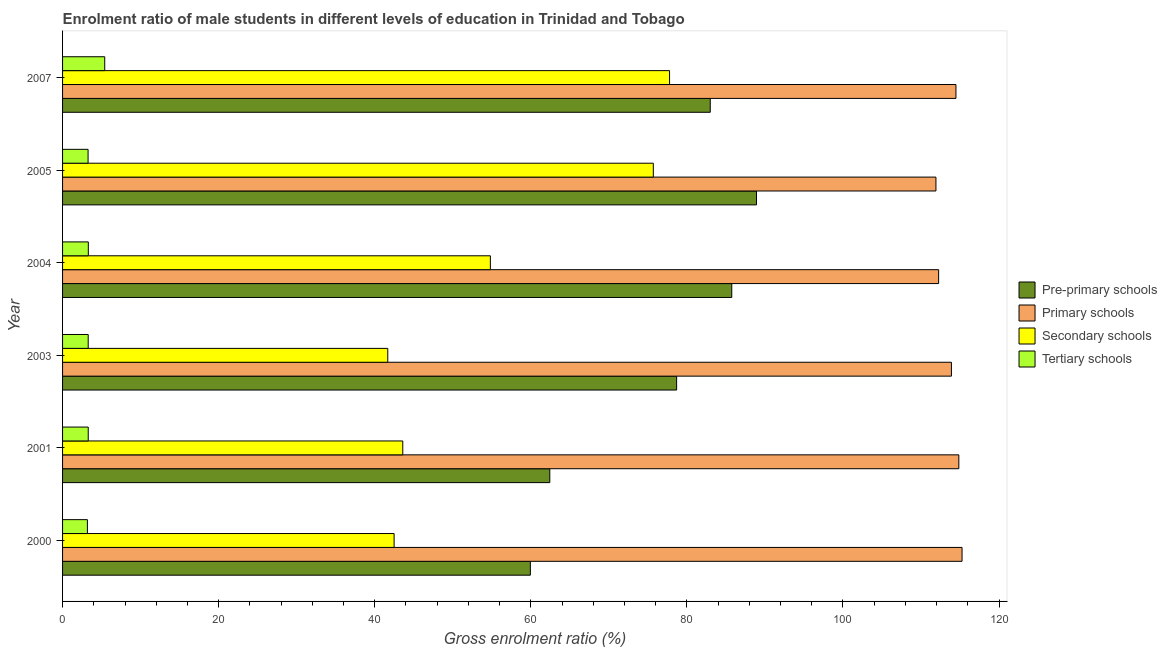Are the number of bars per tick equal to the number of legend labels?
Keep it short and to the point. Yes. How many bars are there on the 2nd tick from the top?
Provide a succinct answer. 4. How many bars are there on the 3rd tick from the bottom?
Give a very brief answer. 4. What is the label of the 6th group of bars from the top?
Provide a succinct answer. 2000. What is the gross enrolment ratio(female) in secondary schools in 2007?
Ensure brevity in your answer.  77.78. Across all years, what is the maximum gross enrolment ratio(female) in pre-primary schools?
Ensure brevity in your answer.  88.92. Across all years, what is the minimum gross enrolment ratio(female) in pre-primary schools?
Ensure brevity in your answer.  59.95. In which year was the gross enrolment ratio(female) in primary schools maximum?
Give a very brief answer. 2000. In which year was the gross enrolment ratio(female) in primary schools minimum?
Your answer should be compact. 2005. What is the total gross enrolment ratio(female) in tertiary schools in the graph?
Offer a very short reply. 21.73. What is the difference between the gross enrolment ratio(female) in primary schools in 2003 and that in 2005?
Ensure brevity in your answer.  1.98. What is the difference between the gross enrolment ratio(female) in secondary schools in 2000 and the gross enrolment ratio(female) in primary schools in 2001?
Keep it short and to the point. -72.37. What is the average gross enrolment ratio(female) in primary schools per year?
Offer a very short reply. 113.78. In the year 2000, what is the difference between the gross enrolment ratio(female) in secondary schools and gross enrolment ratio(female) in tertiary schools?
Make the answer very short. 39.3. What is the ratio of the gross enrolment ratio(female) in primary schools in 2000 to that in 2005?
Provide a succinct answer. 1.03. What is the difference between the highest and the second highest gross enrolment ratio(female) in primary schools?
Ensure brevity in your answer.  0.41. What is the difference between the highest and the lowest gross enrolment ratio(female) in pre-primary schools?
Make the answer very short. 28.98. Is the sum of the gross enrolment ratio(female) in pre-primary schools in 2004 and 2005 greater than the maximum gross enrolment ratio(female) in tertiary schools across all years?
Provide a short and direct response. Yes. What does the 4th bar from the top in 2004 represents?
Ensure brevity in your answer.  Pre-primary schools. What does the 3rd bar from the bottom in 2004 represents?
Make the answer very short. Secondary schools. Is it the case that in every year, the sum of the gross enrolment ratio(female) in pre-primary schools and gross enrolment ratio(female) in primary schools is greater than the gross enrolment ratio(female) in secondary schools?
Your answer should be compact. Yes. How many years are there in the graph?
Keep it short and to the point. 6. What is the difference between two consecutive major ticks on the X-axis?
Provide a short and direct response. 20. Are the values on the major ticks of X-axis written in scientific E-notation?
Make the answer very short. No. Where does the legend appear in the graph?
Keep it short and to the point. Center right. How many legend labels are there?
Your answer should be compact. 4. How are the legend labels stacked?
Your answer should be compact. Vertical. What is the title of the graph?
Give a very brief answer. Enrolment ratio of male students in different levels of education in Trinidad and Tobago. Does "Corruption" appear as one of the legend labels in the graph?
Your response must be concise. No. What is the Gross enrolment ratio (%) of Pre-primary schools in 2000?
Make the answer very short. 59.95. What is the Gross enrolment ratio (%) in Primary schools in 2000?
Offer a terse response. 115.27. What is the Gross enrolment ratio (%) in Secondary schools in 2000?
Provide a succinct answer. 42.49. What is the Gross enrolment ratio (%) in Tertiary schools in 2000?
Your answer should be very brief. 3.18. What is the Gross enrolment ratio (%) in Pre-primary schools in 2001?
Your response must be concise. 62.44. What is the Gross enrolment ratio (%) in Primary schools in 2001?
Offer a very short reply. 114.85. What is the Gross enrolment ratio (%) in Secondary schools in 2001?
Your answer should be compact. 43.6. What is the Gross enrolment ratio (%) of Tertiary schools in 2001?
Offer a very short reply. 3.29. What is the Gross enrolment ratio (%) of Pre-primary schools in 2003?
Offer a terse response. 78.69. What is the Gross enrolment ratio (%) in Primary schools in 2003?
Give a very brief answer. 113.9. What is the Gross enrolment ratio (%) in Secondary schools in 2003?
Your response must be concise. 41.67. What is the Gross enrolment ratio (%) of Tertiary schools in 2003?
Offer a terse response. 3.28. What is the Gross enrolment ratio (%) of Pre-primary schools in 2004?
Offer a very short reply. 85.75. What is the Gross enrolment ratio (%) in Primary schools in 2004?
Give a very brief answer. 112.26. What is the Gross enrolment ratio (%) of Secondary schools in 2004?
Make the answer very short. 54.82. What is the Gross enrolment ratio (%) in Tertiary schools in 2004?
Your answer should be very brief. 3.3. What is the Gross enrolment ratio (%) in Pre-primary schools in 2005?
Your answer should be very brief. 88.92. What is the Gross enrolment ratio (%) in Primary schools in 2005?
Your response must be concise. 111.92. What is the Gross enrolment ratio (%) of Secondary schools in 2005?
Your response must be concise. 75.7. What is the Gross enrolment ratio (%) of Tertiary schools in 2005?
Offer a terse response. 3.27. What is the Gross enrolment ratio (%) in Pre-primary schools in 2007?
Provide a short and direct response. 83. What is the Gross enrolment ratio (%) in Primary schools in 2007?
Give a very brief answer. 114.48. What is the Gross enrolment ratio (%) in Secondary schools in 2007?
Offer a very short reply. 77.78. What is the Gross enrolment ratio (%) of Tertiary schools in 2007?
Your response must be concise. 5.4. Across all years, what is the maximum Gross enrolment ratio (%) of Pre-primary schools?
Provide a short and direct response. 88.92. Across all years, what is the maximum Gross enrolment ratio (%) in Primary schools?
Ensure brevity in your answer.  115.27. Across all years, what is the maximum Gross enrolment ratio (%) of Secondary schools?
Keep it short and to the point. 77.78. Across all years, what is the maximum Gross enrolment ratio (%) in Tertiary schools?
Provide a short and direct response. 5.4. Across all years, what is the minimum Gross enrolment ratio (%) in Pre-primary schools?
Offer a very short reply. 59.95. Across all years, what is the minimum Gross enrolment ratio (%) in Primary schools?
Your response must be concise. 111.92. Across all years, what is the minimum Gross enrolment ratio (%) of Secondary schools?
Your answer should be very brief. 41.67. Across all years, what is the minimum Gross enrolment ratio (%) of Tertiary schools?
Offer a very short reply. 3.18. What is the total Gross enrolment ratio (%) in Pre-primary schools in the graph?
Your answer should be compact. 458.75. What is the total Gross enrolment ratio (%) of Primary schools in the graph?
Provide a short and direct response. 682.69. What is the total Gross enrolment ratio (%) in Secondary schools in the graph?
Your answer should be very brief. 336.06. What is the total Gross enrolment ratio (%) of Tertiary schools in the graph?
Give a very brief answer. 21.73. What is the difference between the Gross enrolment ratio (%) of Pre-primary schools in 2000 and that in 2001?
Your answer should be very brief. -2.49. What is the difference between the Gross enrolment ratio (%) of Primary schools in 2000 and that in 2001?
Your answer should be very brief. 0.41. What is the difference between the Gross enrolment ratio (%) in Secondary schools in 2000 and that in 2001?
Your response must be concise. -1.11. What is the difference between the Gross enrolment ratio (%) of Tertiary schools in 2000 and that in 2001?
Give a very brief answer. -0.1. What is the difference between the Gross enrolment ratio (%) of Pre-primary schools in 2000 and that in 2003?
Offer a very short reply. -18.74. What is the difference between the Gross enrolment ratio (%) of Primary schools in 2000 and that in 2003?
Make the answer very short. 1.36. What is the difference between the Gross enrolment ratio (%) in Secondary schools in 2000 and that in 2003?
Provide a succinct answer. 0.81. What is the difference between the Gross enrolment ratio (%) of Tertiary schools in 2000 and that in 2003?
Your answer should be very brief. -0.1. What is the difference between the Gross enrolment ratio (%) in Pre-primary schools in 2000 and that in 2004?
Your response must be concise. -25.81. What is the difference between the Gross enrolment ratio (%) of Primary schools in 2000 and that in 2004?
Ensure brevity in your answer.  3. What is the difference between the Gross enrolment ratio (%) of Secondary schools in 2000 and that in 2004?
Keep it short and to the point. -12.33. What is the difference between the Gross enrolment ratio (%) of Tertiary schools in 2000 and that in 2004?
Offer a very short reply. -0.12. What is the difference between the Gross enrolment ratio (%) of Pre-primary schools in 2000 and that in 2005?
Your answer should be compact. -28.98. What is the difference between the Gross enrolment ratio (%) of Primary schools in 2000 and that in 2005?
Provide a short and direct response. 3.35. What is the difference between the Gross enrolment ratio (%) in Secondary schools in 2000 and that in 2005?
Give a very brief answer. -33.22. What is the difference between the Gross enrolment ratio (%) in Tertiary schools in 2000 and that in 2005?
Your answer should be very brief. -0.09. What is the difference between the Gross enrolment ratio (%) in Pre-primary schools in 2000 and that in 2007?
Keep it short and to the point. -23.05. What is the difference between the Gross enrolment ratio (%) of Primary schools in 2000 and that in 2007?
Your answer should be very brief. 0.78. What is the difference between the Gross enrolment ratio (%) of Secondary schools in 2000 and that in 2007?
Offer a very short reply. -35.3. What is the difference between the Gross enrolment ratio (%) in Tertiary schools in 2000 and that in 2007?
Your answer should be very brief. -2.22. What is the difference between the Gross enrolment ratio (%) of Pre-primary schools in 2001 and that in 2003?
Offer a very short reply. -16.25. What is the difference between the Gross enrolment ratio (%) of Primary schools in 2001 and that in 2003?
Provide a succinct answer. 0.95. What is the difference between the Gross enrolment ratio (%) in Secondary schools in 2001 and that in 2003?
Your response must be concise. 1.92. What is the difference between the Gross enrolment ratio (%) in Tertiary schools in 2001 and that in 2003?
Keep it short and to the point. 0. What is the difference between the Gross enrolment ratio (%) of Pre-primary schools in 2001 and that in 2004?
Your response must be concise. -23.32. What is the difference between the Gross enrolment ratio (%) of Primary schools in 2001 and that in 2004?
Your answer should be very brief. 2.59. What is the difference between the Gross enrolment ratio (%) of Secondary schools in 2001 and that in 2004?
Offer a very short reply. -11.22. What is the difference between the Gross enrolment ratio (%) of Tertiary schools in 2001 and that in 2004?
Ensure brevity in your answer.  -0.01. What is the difference between the Gross enrolment ratio (%) of Pre-primary schools in 2001 and that in 2005?
Make the answer very short. -26.49. What is the difference between the Gross enrolment ratio (%) of Primary schools in 2001 and that in 2005?
Make the answer very short. 2.93. What is the difference between the Gross enrolment ratio (%) of Secondary schools in 2001 and that in 2005?
Make the answer very short. -32.1. What is the difference between the Gross enrolment ratio (%) in Tertiary schools in 2001 and that in 2005?
Your answer should be very brief. 0.02. What is the difference between the Gross enrolment ratio (%) in Pre-primary schools in 2001 and that in 2007?
Ensure brevity in your answer.  -20.56. What is the difference between the Gross enrolment ratio (%) of Primary schools in 2001 and that in 2007?
Keep it short and to the point. 0.37. What is the difference between the Gross enrolment ratio (%) in Secondary schools in 2001 and that in 2007?
Your answer should be very brief. -34.19. What is the difference between the Gross enrolment ratio (%) of Tertiary schools in 2001 and that in 2007?
Ensure brevity in your answer.  -2.11. What is the difference between the Gross enrolment ratio (%) in Pre-primary schools in 2003 and that in 2004?
Ensure brevity in your answer.  -7.07. What is the difference between the Gross enrolment ratio (%) of Primary schools in 2003 and that in 2004?
Ensure brevity in your answer.  1.64. What is the difference between the Gross enrolment ratio (%) in Secondary schools in 2003 and that in 2004?
Provide a succinct answer. -13.15. What is the difference between the Gross enrolment ratio (%) in Tertiary schools in 2003 and that in 2004?
Give a very brief answer. -0.02. What is the difference between the Gross enrolment ratio (%) in Pre-primary schools in 2003 and that in 2005?
Your answer should be very brief. -10.24. What is the difference between the Gross enrolment ratio (%) of Primary schools in 2003 and that in 2005?
Keep it short and to the point. 1.98. What is the difference between the Gross enrolment ratio (%) of Secondary schools in 2003 and that in 2005?
Your answer should be very brief. -34.03. What is the difference between the Gross enrolment ratio (%) in Tertiary schools in 2003 and that in 2005?
Give a very brief answer. 0.01. What is the difference between the Gross enrolment ratio (%) of Pre-primary schools in 2003 and that in 2007?
Offer a terse response. -4.31. What is the difference between the Gross enrolment ratio (%) of Primary schools in 2003 and that in 2007?
Offer a terse response. -0.58. What is the difference between the Gross enrolment ratio (%) of Secondary schools in 2003 and that in 2007?
Your response must be concise. -36.11. What is the difference between the Gross enrolment ratio (%) in Tertiary schools in 2003 and that in 2007?
Offer a terse response. -2.12. What is the difference between the Gross enrolment ratio (%) of Pre-primary schools in 2004 and that in 2005?
Your response must be concise. -3.17. What is the difference between the Gross enrolment ratio (%) in Primary schools in 2004 and that in 2005?
Keep it short and to the point. 0.34. What is the difference between the Gross enrolment ratio (%) of Secondary schools in 2004 and that in 2005?
Ensure brevity in your answer.  -20.88. What is the difference between the Gross enrolment ratio (%) in Tertiary schools in 2004 and that in 2005?
Your answer should be very brief. 0.03. What is the difference between the Gross enrolment ratio (%) in Pre-primary schools in 2004 and that in 2007?
Make the answer very short. 2.76. What is the difference between the Gross enrolment ratio (%) in Primary schools in 2004 and that in 2007?
Offer a terse response. -2.22. What is the difference between the Gross enrolment ratio (%) of Secondary schools in 2004 and that in 2007?
Your answer should be compact. -22.96. What is the difference between the Gross enrolment ratio (%) in Tertiary schools in 2004 and that in 2007?
Make the answer very short. -2.1. What is the difference between the Gross enrolment ratio (%) of Pre-primary schools in 2005 and that in 2007?
Make the answer very short. 5.93. What is the difference between the Gross enrolment ratio (%) in Primary schools in 2005 and that in 2007?
Make the answer very short. -2.56. What is the difference between the Gross enrolment ratio (%) of Secondary schools in 2005 and that in 2007?
Offer a very short reply. -2.08. What is the difference between the Gross enrolment ratio (%) of Tertiary schools in 2005 and that in 2007?
Provide a short and direct response. -2.13. What is the difference between the Gross enrolment ratio (%) of Pre-primary schools in 2000 and the Gross enrolment ratio (%) of Primary schools in 2001?
Offer a very short reply. -54.91. What is the difference between the Gross enrolment ratio (%) of Pre-primary schools in 2000 and the Gross enrolment ratio (%) of Secondary schools in 2001?
Keep it short and to the point. 16.35. What is the difference between the Gross enrolment ratio (%) in Pre-primary schools in 2000 and the Gross enrolment ratio (%) in Tertiary schools in 2001?
Ensure brevity in your answer.  56.66. What is the difference between the Gross enrolment ratio (%) in Primary schools in 2000 and the Gross enrolment ratio (%) in Secondary schools in 2001?
Offer a terse response. 71.67. What is the difference between the Gross enrolment ratio (%) of Primary schools in 2000 and the Gross enrolment ratio (%) of Tertiary schools in 2001?
Make the answer very short. 111.98. What is the difference between the Gross enrolment ratio (%) of Secondary schools in 2000 and the Gross enrolment ratio (%) of Tertiary schools in 2001?
Keep it short and to the point. 39.2. What is the difference between the Gross enrolment ratio (%) in Pre-primary schools in 2000 and the Gross enrolment ratio (%) in Primary schools in 2003?
Provide a succinct answer. -53.96. What is the difference between the Gross enrolment ratio (%) in Pre-primary schools in 2000 and the Gross enrolment ratio (%) in Secondary schools in 2003?
Offer a very short reply. 18.27. What is the difference between the Gross enrolment ratio (%) of Pre-primary schools in 2000 and the Gross enrolment ratio (%) of Tertiary schools in 2003?
Your response must be concise. 56.66. What is the difference between the Gross enrolment ratio (%) of Primary schools in 2000 and the Gross enrolment ratio (%) of Secondary schools in 2003?
Provide a succinct answer. 73.59. What is the difference between the Gross enrolment ratio (%) of Primary schools in 2000 and the Gross enrolment ratio (%) of Tertiary schools in 2003?
Give a very brief answer. 111.98. What is the difference between the Gross enrolment ratio (%) in Secondary schools in 2000 and the Gross enrolment ratio (%) in Tertiary schools in 2003?
Provide a succinct answer. 39.2. What is the difference between the Gross enrolment ratio (%) in Pre-primary schools in 2000 and the Gross enrolment ratio (%) in Primary schools in 2004?
Keep it short and to the point. -52.32. What is the difference between the Gross enrolment ratio (%) in Pre-primary schools in 2000 and the Gross enrolment ratio (%) in Secondary schools in 2004?
Keep it short and to the point. 5.12. What is the difference between the Gross enrolment ratio (%) in Pre-primary schools in 2000 and the Gross enrolment ratio (%) in Tertiary schools in 2004?
Offer a very short reply. 56.65. What is the difference between the Gross enrolment ratio (%) of Primary schools in 2000 and the Gross enrolment ratio (%) of Secondary schools in 2004?
Your response must be concise. 60.44. What is the difference between the Gross enrolment ratio (%) of Primary schools in 2000 and the Gross enrolment ratio (%) of Tertiary schools in 2004?
Give a very brief answer. 111.97. What is the difference between the Gross enrolment ratio (%) of Secondary schools in 2000 and the Gross enrolment ratio (%) of Tertiary schools in 2004?
Your answer should be compact. 39.19. What is the difference between the Gross enrolment ratio (%) of Pre-primary schools in 2000 and the Gross enrolment ratio (%) of Primary schools in 2005?
Your answer should be very brief. -51.97. What is the difference between the Gross enrolment ratio (%) in Pre-primary schools in 2000 and the Gross enrolment ratio (%) in Secondary schools in 2005?
Your answer should be compact. -15.76. What is the difference between the Gross enrolment ratio (%) in Pre-primary schools in 2000 and the Gross enrolment ratio (%) in Tertiary schools in 2005?
Ensure brevity in your answer.  56.68. What is the difference between the Gross enrolment ratio (%) in Primary schools in 2000 and the Gross enrolment ratio (%) in Secondary schools in 2005?
Provide a short and direct response. 39.56. What is the difference between the Gross enrolment ratio (%) of Primary schools in 2000 and the Gross enrolment ratio (%) of Tertiary schools in 2005?
Ensure brevity in your answer.  112. What is the difference between the Gross enrolment ratio (%) in Secondary schools in 2000 and the Gross enrolment ratio (%) in Tertiary schools in 2005?
Make the answer very short. 39.22. What is the difference between the Gross enrolment ratio (%) of Pre-primary schools in 2000 and the Gross enrolment ratio (%) of Primary schools in 2007?
Offer a very short reply. -54.54. What is the difference between the Gross enrolment ratio (%) of Pre-primary schools in 2000 and the Gross enrolment ratio (%) of Secondary schools in 2007?
Offer a terse response. -17.84. What is the difference between the Gross enrolment ratio (%) of Pre-primary schools in 2000 and the Gross enrolment ratio (%) of Tertiary schools in 2007?
Keep it short and to the point. 54.54. What is the difference between the Gross enrolment ratio (%) in Primary schools in 2000 and the Gross enrolment ratio (%) in Secondary schools in 2007?
Provide a succinct answer. 37.48. What is the difference between the Gross enrolment ratio (%) of Primary schools in 2000 and the Gross enrolment ratio (%) of Tertiary schools in 2007?
Provide a succinct answer. 109.86. What is the difference between the Gross enrolment ratio (%) of Secondary schools in 2000 and the Gross enrolment ratio (%) of Tertiary schools in 2007?
Keep it short and to the point. 37.08. What is the difference between the Gross enrolment ratio (%) in Pre-primary schools in 2001 and the Gross enrolment ratio (%) in Primary schools in 2003?
Your answer should be very brief. -51.47. What is the difference between the Gross enrolment ratio (%) in Pre-primary schools in 2001 and the Gross enrolment ratio (%) in Secondary schools in 2003?
Offer a very short reply. 20.76. What is the difference between the Gross enrolment ratio (%) in Pre-primary schools in 2001 and the Gross enrolment ratio (%) in Tertiary schools in 2003?
Make the answer very short. 59.15. What is the difference between the Gross enrolment ratio (%) in Primary schools in 2001 and the Gross enrolment ratio (%) in Secondary schools in 2003?
Offer a terse response. 73.18. What is the difference between the Gross enrolment ratio (%) in Primary schools in 2001 and the Gross enrolment ratio (%) in Tertiary schools in 2003?
Provide a succinct answer. 111.57. What is the difference between the Gross enrolment ratio (%) of Secondary schools in 2001 and the Gross enrolment ratio (%) of Tertiary schools in 2003?
Ensure brevity in your answer.  40.31. What is the difference between the Gross enrolment ratio (%) of Pre-primary schools in 2001 and the Gross enrolment ratio (%) of Primary schools in 2004?
Offer a very short reply. -49.83. What is the difference between the Gross enrolment ratio (%) in Pre-primary schools in 2001 and the Gross enrolment ratio (%) in Secondary schools in 2004?
Give a very brief answer. 7.62. What is the difference between the Gross enrolment ratio (%) of Pre-primary schools in 2001 and the Gross enrolment ratio (%) of Tertiary schools in 2004?
Make the answer very short. 59.14. What is the difference between the Gross enrolment ratio (%) in Primary schools in 2001 and the Gross enrolment ratio (%) in Secondary schools in 2004?
Your answer should be compact. 60.03. What is the difference between the Gross enrolment ratio (%) of Primary schools in 2001 and the Gross enrolment ratio (%) of Tertiary schools in 2004?
Ensure brevity in your answer.  111.55. What is the difference between the Gross enrolment ratio (%) of Secondary schools in 2001 and the Gross enrolment ratio (%) of Tertiary schools in 2004?
Give a very brief answer. 40.3. What is the difference between the Gross enrolment ratio (%) of Pre-primary schools in 2001 and the Gross enrolment ratio (%) of Primary schools in 2005?
Keep it short and to the point. -49.48. What is the difference between the Gross enrolment ratio (%) in Pre-primary schools in 2001 and the Gross enrolment ratio (%) in Secondary schools in 2005?
Offer a terse response. -13.27. What is the difference between the Gross enrolment ratio (%) of Pre-primary schools in 2001 and the Gross enrolment ratio (%) of Tertiary schools in 2005?
Offer a very short reply. 59.17. What is the difference between the Gross enrolment ratio (%) in Primary schools in 2001 and the Gross enrolment ratio (%) in Secondary schools in 2005?
Ensure brevity in your answer.  39.15. What is the difference between the Gross enrolment ratio (%) in Primary schools in 2001 and the Gross enrolment ratio (%) in Tertiary schools in 2005?
Give a very brief answer. 111.58. What is the difference between the Gross enrolment ratio (%) in Secondary schools in 2001 and the Gross enrolment ratio (%) in Tertiary schools in 2005?
Provide a succinct answer. 40.33. What is the difference between the Gross enrolment ratio (%) of Pre-primary schools in 2001 and the Gross enrolment ratio (%) of Primary schools in 2007?
Offer a very short reply. -52.05. What is the difference between the Gross enrolment ratio (%) in Pre-primary schools in 2001 and the Gross enrolment ratio (%) in Secondary schools in 2007?
Your answer should be very brief. -15.35. What is the difference between the Gross enrolment ratio (%) in Pre-primary schools in 2001 and the Gross enrolment ratio (%) in Tertiary schools in 2007?
Provide a short and direct response. 57.03. What is the difference between the Gross enrolment ratio (%) in Primary schools in 2001 and the Gross enrolment ratio (%) in Secondary schools in 2007?
Offer a very short reply. 37.07. What is the difference between the Gross enrolment ratio (%) in Primary schools in 2001 and the Gross enrolment ratio (%) in Tertiary schools in 2007?
Ensure brevity in your answer.  109.45. What is the difference between the Gross enrolment ratio (%) of Secondary schools in 2001 and the Gross enrolment ratio (%) of Tertiary schools in 2007?
Offer a very short reply. 38.19. What is the difference between the Gross enrolment ratio (%) in Pre-primary schools in 2003 and the Gross enrolment ratio (%) in Primary schools in 2004?
Offer a terse response. -33.57. What is the difference between the Gross enrolment ratio (%) in Pre-primary schools in 2003 and the Gross enrolment ratio (%) in Secondary schools in 2004?
Provide a short and direct response. 23.87. What is the difference between the Gross enrolment ratio (%) in Pre-primary schools in 2003 and the Gross enrolment ratio (%) in Tertiary schools in 2004?
Your response must be concise. 75.39. What is the difference between the Gross enrolment ratio (%) of Primary schools in 2003 and the Gross enrolment ratio (%) of Secondary schools in 2004?
Your response must be concise. 59.08. What is the difference between the Gross enrolment ratio (%) in Primary schools in 2003 and the Gross enrolment ratio (%) in Tertiary schools in 2004?
Provide a succinct answer. 110.6. What is the difference between the Gross enrolment ratio (%) of Secondary schools in 2003 and the Gross enrolment ratio (%) of Tertiary schools in 2004?
Provide a succinct answer. 38.37. What is the difference between the Gross enrolment ratio (%) of Pre-primary schools in 2003 and the Gross enrolment ratio (%) of Primary schools in 2005?
Give a very brief answer. -33.23. What is the difference between the Gross enrolment ratio (%) of Pre-primary schools in 2003 and the Gross enrolment ratio (%) of Secondary schools in 2005?
Offer a very short reply. 2.99. What is the difference between the Gross enrolment ratio (%) in Pre-primary schools in 2003 and the Gross enrolment ratio (%) in Tertiary schools in 2005?
Keep it short and to the point. 75.42. What is the difference between the Gross enrolment ratio (%) of Primary schools in 2003 and the Gross enrolment ratio (%) of Secondary schools in 2005?
Your answer should be very brief. 38.2. What is the difference between the Gross enrolment ratio (%) of Primary schools in 2003 and the Gross enrolment ratio (%) of Tertiary schools in 2005?
Make the answer very short. 110.63. What is the difference between the Gross enrolment ratio (%) of Secondary schools in 2003 and the Gross enrolment ratio (%) of Tertiary schools in 2005?
Offer a very short reply. 38.4. What is the difference between the Gross enrolment ratio (%) in Pre-primary schools in 2003 and the Gross enrolment ratio (%) in Primary schools in 2007?
Provide a succinct answer. -35.8. What is the difference between the Gross enrolment ratio (%) of Pre-primary schools in 2003 and the Gross enrolment ratio (%) of Secondary schools in 2007?
Provide a short and direct response. 0.91. What is the difference between the Gross enrolment ratio (%) of Pre-primary schools in 2003 and the Gross enrolment ratio (%) of Tertiary schools in 2007?
Offer a terse response. 73.29. What is the difference between the Gross enrolment ratio (%) in Primary schools in 2003 and the Gross enrolment ratio (%) in Secondary schools in 2007?
Offer a terse response. 36.12. What is the difference between the Gross enrolment ratio (%) in Primary schools in 2003 and the Gross enrolment ratio (%) in Tertiary schools in 2007?
Your answer should be compact. 108.5. What is the difference between the Gross enrolment ratio (%) in Secondary schools in 2003 and the Gross enrolment ratio (%) in Tertiary schools in 2007?
Offer a terse response. 36.27. What is the difference between the Gross enrolment ratio (%) of Pre-primary schools in 2004 and the Gross enrolment ratio (%) of Primary schools in 2005?
Make the answer very short. -26.16. What is the difference between the Gross enrolment ratio (%) in Pre-primary schools in 2004 and the Gross enrolment ratio (%) in Secondary schools in 2005?
Give a very brief answer. 10.05. What is the difference between the Gross enrolment ratio (%) in Pre-primary schools in 2004 and the Gross enrolment ratio (%) in Tertiary schools in 2005?
Offer a terse response. 82.48. What is the difference between the Gross enrolment ratio (%) of Primary schools in 2004 and the Gross enrolment ratio (%) of Secondary schools in 2005?
Provide a succinct answer. 36.56. What is the difference between the Gross enrolment ratio (%) of Primary schools in 2004 and the Gross enrolment ratio (%) of Tertiary schools in 2005?
Offer a terse response. 108.99. What is the difference between the Gross enrolment ratio (%) in Secondary schools in 2004 and the Gross enrolment ratio (%) in Tertiary schools in 2005?
Your response must be concise. 51.55. What is the difference between the Gross enrolment ratio (%) in Pre-primary schools in 2004 and the Gross enrolment ratio (%) in Primary schools in 2007?
Keep it short and to the point. -28.73. What is the difference between the Gross enrolment ratio (%) of Pre-primary schools in 2004 and the Gross enrolment ratio (%) of Secondary schools in 2007?
Your response must be concise. 7.97. What is the difference between the Gross enrolment ratio (%) in Pre-primary schools in 2004 and the Gross enrolment ratio (%) in Tertiary schools in 2007?
Offer a very short reply. 80.35. What is the difference between the Gross enrolment ratio (%) in Primary schools in 2004 and the Gross enrolment ratio (%) in Secondary schools in 2007?
Your answer should be compact. 34.48. What is the difference between the Gross enrolment ratio (%) of Primary schools in 2004 and the Gross enrolment ratio (%) of Tertiary schools in 2007?
Your answer should be compact. 106.86. What is the difference between the Gross enrolment ratio (%) in Secondary schools in 2004 and the Gross enrolment ratio (%) in Tertiary schools in 2007?
Your answer should be very brief. 49.42. What is the difference between the Gross enrolment ratio (%) in Pre-primary schools in 2005 and the Gross enrolment ratio (%) in Primary schools in 2007?
Keep it short and to the point. -25.56. What is the difference between the Gross enrolment ratio (%) in Pre-primary schools in 2005 and the Gross enrolment ratio (%) in Secondary schools in 2007?
Offer a terse response. 11.14. What is the difference between the Gross enrolment ratio (%) of Pre-primary schools in 2005 and the Gross enrolment ratio (%) of Tertiary schools in 2007?
Your answer should be very brief. 83.52. What is the difference between the Gross enrolment ratio (%) of Primary schools in 2005 and the Gross enrolment ratio (%) of Secondary schools in 2007?
Your answer should be very brief. 34.14. What is the difference between the Gross enrolment ratio (%) in Primary schools in 2005 and the Gross enrolment ratio (%) in Tertiary schools in 2007?
Offer a very short reply. 106.52. What is the difference between the Gross enrolment ratio (%) in Secondary schools in 2005 and the Gross enrolment ratio (%) in Tertiary schools in 2007?
Keep it short and to the point. 70.3. What is the average Gross enrolment ratio (%) of Pre-primary schools per year?
Your response must be concise. 76.46. What is the average Gross enrolment ratio (%) of Primary schools per year?
Your answer should be very brief. 113.78. What is the average Gross enrolment ratio (%) in Secondary schools per year?
Offer a terse response. 56.01. What is the average Gross enrolment ratio (%) in Tertiary schools per year?
Keep it short and to the point. 3.62. In the year 2000, what is the difference between the Gross enrolment ratio (%) in Pre-primary schools and Gross enrolment ratio (%) in Primary schools?
Ensure brevity in your answer.  -55.32. In the year 2000, what is the difference between the Gross enrolment ratio (%) of Pre-primary schools and Gross enrolment ratio (%) of Secondary schools?
Ensure brevity in your answer.  17.46. In the year 2000, what is the difference between the Gross enrolment ratio (%) in Pre-primary schools and Gross enrolment ratio (%) in Tertiary schools?
Offer a terse response. 56.76. In the year 2000, what is the difference between the Gross enrolment ratio (%) of Primary schools and Gross enrolment ratio (%) of Secondary schools?
Give a very brief answer. 72.78. In the year 2000, what is the difference between the Gross enrolment ratio (%) of Primary schools and Gross enrolment ratio (%) of Tertiary schools?
Keep it short and to the point. 112.08. In the year 2000, what is the difference between the Gross enrolment ratio (%) of Secondary schools and Gross enrolment ratio (%) of Tertiary schools?
Provide a short and direct response. 39.3. In the year 2001, what is the difference between the Gross enrolment ratio (%) in Pre-primary schools and Gross enrolment ratio (%) in Primary schools?
Offer a terse response. -52.42. In the year 2001, what is the difference between the Gross enrolment ratio (%) of Pre-primary schools and Gross enrolment ratio (%) of Secondary schools?
Provide a short and direct response. 18.84. In the year 2001, what is the difference between the Gross enrolment ratio (%) in Pre-primary schools and Gross enrolment ratio (%) in Tertiary schools?
Offer a very short reply. 59.15. In the year 2001, what is the difference between the Gross enrolment ratio (%) in Primary schools and Gross enrolment ratio (%) in Secondary schools?
Keep it short and to the point. 71.26. In the year 2001, what is the difference between the Gross enrolment ratio (%) of Primary schools and Gross enrolment ratio (%) of Tertiary schools?
Offer a very short reply. 111.56. In the year 2001, what is the difference between the Gross enrolment ratio (%) of Secondary schools and Gross enrolment ratio (%) of Tertiary schools?
Keep it short and to the point. 40.31. In the year 2003, what is the difference between the Gross enrolment ratio (%) of Pre-primary schools and Gross enrolment ratio (%) of Primary schools?
Offer a terse response. -35.21. In the year 2003, what is the difference between the Gross enrolment ratio (%) of Pre-primary schools and Gross enrolment ratio (%) of Secondary schools?
Provide a succinct answer. 37.02. In the year 2003, what is the difference between the Gross enrolment ratio (%) in Pre-primary schools and Gross enrolment ratio (%) in Tertiary schools?
Offer a terse response. 75.4. In the year 2003, what is the difference between the Gross enrolment ratio (%) in Primary schools and Gross enrolment ratio (%) in Secondary schools?
Your answer should be very brief. 72.23. In the year 2003, what is the difference between the Gross enrolment ratio (%) in Primary schools and Gross enrolment ratio (%) in Tertiary schools?
Offer a very short reply. 110.62. In the year 2003, what is the difference between the Gross enrolment ratio (%) in Secondary schools and Gross enrolment ratio (%) in Tertiary schools?
Your response must be concise. 38.39. In the year 2004, what is the difference between the Gross enrolment ratio (%) in Pre-primary schools and Gross enrolment ratio (%) in Primary schools?
Provide a succinct answer. -26.51. In the year 2004, what is the difference between the Gross enrolment ratio (%) of Pre-primary schools and Gross enrolment ratio (%) of Secondary schools?
Give a very brief answer. 30.93. In the year 2004, what is the difference between the Gross enrolment ratio (%) of Pre-primary schools and Gross enrolment ratio (%) of Tertiary schools?
Provide a short and direct response. 82.45. In the year 2004, what is the difference between the Gross enrolment ratio (%) of Primary schools and Gross enrolment ratio (%) of Secondary schools?
Keep it short and to the point. 57.44. In the year 2004, what is the difference between the Gross enrolment ratio (%) of Primary schools and Gross enrolment ratio (%) of Tertiary schools?
Your answer should be very brief. 108.96. In the year 2004, what is the difference between the Gross enrolment ratio (%) in Secondary schools and Gross enrolment ratio (%) in Tertiary schools?
Keep it short and to the point. 51.52. In the year 2005, what is the difference between the Gross enrolment ratio (%) of Pre-primary schools and Gross enrolment ratio (%) of Primary schools?
Your answer should be very brief. -22.99. In the year 2005, what is the difference between the Gross enrolment ratio (%) of Pre-primary schools and Gross enrolment ratio (%) of Secondary schools?
Ensure brevity in your answer.  13.22. In the year 2005, what is the difference between the Gross enrolment ratio (%) in Pre-primary schools and Gross enrolment ratio (%) in Tertiary schools?
Give a very brief answer. 85.65. In the year 2005, what is the difference between the Gross enrolment ratio (%) in Primary schools and Gross enrolment ratio (%) in Secondary schools?
Give a very brief answer. 36.22. In the year 2005, what is the difference between the Gross enrolment ratio (%) of Primary schools and Gross enrolment ratio (%) of Tertiary schools?
Ensure brevity in your answer.  108.65. In the year 2005, what is the difference between the Gross enrolment ratio (%) in Secondary schools and Gross enrolment ratio (%) in Tertiary schools?
Your answer should be compact. 72.43. In the year 2007, what is the difference between the Gross enrolment ratio (%) in Pre-primary schools and Gross enrolment ratio (%) in Primary schools?
Provide a succinct answer. -31.49. In the year 2007, what is the difference between the Gross enrolment ratio (%) in Pre-primary schools and Gross enrolment ratio (%) in Secondary schools?
Offer a terse response. 5.21. In the year 2007, what is the difference between the Gross enrolment ratio (%) of Pre-primary schools and Gross enrolment ratio (%) of Tertiary schools?
Provide a short and direct response. 77.6. In the year 2007, what is the difference between the Gross enrolment ratio (%) of Primary schools and Gross enrolment ratio (%) of Secondary schools?
Your response must be concise. 36.7. In the year 2007, what is the difference between the Gross enrolment ratio (%) in Primary schools and Gross enrolment ratio (%) in Tertiary schools?
Your response must be concise. 109.08. In the year 2007, what is the difference between the Gross enrolment ratio (%) of Secondary schools and Gross enrolment ratio (%) of Tertiary schools?
Make the answer very short. 72.38. What is the ratio of the Gross enrolment ratio (%) of Pre-primary schools in 2000 to that in 2001?
Your answer should be very brief. 0.96. What is the ratio of the Gross enrolment ratio (%) in Primary schools in 2000 to that in 2001?
Offer a terse response. 1. What is the ratio of the Gross enrolment ratio (%) of Secondary schools in 2000 to that in 2001?
Ensure brevity in your answer.  0.97. What is the ratio of the Gross enrolment ratio (%) of Tertiary schools in 2000 to that in 2001?
Make the answer very short. 0.97. What is the ratio of the Gross enrolment ratio (%) of Pre-primary schools in 2000 to that in 2003?
Provide a short and direct response. 0.76. What is the ratio of the Gross enrolment ratio (%) in Secondary schools in 2000 to that in 2003?
Offer a very short reply. 1.02. What is the ratio of the Gross enrolment ratio (%) of Tertiary schools in 2000 to that in 2003?
Your answer should be compact. 0.97. What is the ratio of the Gross enrolment ratio (%) in Pre-primary schools in 2000 to that in 2004?
Ensure brevity in your answer.  0.7. What is the ratio of the Gross enrolment ratio (%) of Primary schools in 2000 to that in 2004?
Give a very brief answer. 1.03. What is the ratio of the Gross enrolment ratio (%) in Secondary schools in 2000 to that in 2004?
Ensure brevity in your answer.  0.78. What is the ratio of the Gross enrolment ratio (%) of Tertiary schools in 2000 to that in 2004?
Offer a terse response. 0.96. What is the ratio of the Gross enrolment ratio (%) of Pre-primary schools in 2000 to that in 2005?
Your response must be concise. 0.67. What is the ratio of the Gross enrolment ratio (%) in Primary schools in 2000 to that in 2005?
Provide a short and direct response. 1.03. What is the ratio of the Gross enrolment ratio (%) of Secondary schools in 2000 to that in 2005?
Offer a terse response. 0.56. What is the ratio of the Gross enrolment ratio (%) of Tertiary schools in 2000 to that in 2005?
Make the answer very short. 0.97. What is the ratio of the Gross enrolment ratio (%) in Pre-primary schools in 2000 to that in 2007?
Make the answer very short. 0.72. What is the ratio of the Gross enrolment ratio (%) of Primary schools in 2000 to that in 2007?
Ensure brevity in your answer.  1.01. What is the ratio of the Gross enrolment ratio (%) in Secondary schools in 2000 to that in 2007?
Provide a short and direct response. 0.55. What is the ratio of the Gross enrolment ratio (%) in Tertiary schools in 2000 to that in 2007?
Provide a succinct answer. 0.59. What is the ratio of the Gross enrolment ratio (%) of Pre-primary schools in 2001 to that in 2003?
Your answer should be very brief. 0.79. What is the ratio of the Gross enrolment ratio (%) of Primary schools in 2001 to that in 2003?
Offer a very short reply. 1.01. What is the ratio of the Gross enrolment ratio (%) in Secondary schools in 2001 to that in 2003?
Offer a terse response. 1.05. What is the ratio of the Gross enrolment ratio (%) in Tertiary schools in 2001 to that in 2003?
Give a very brief answer. 1. What is the ratio of the Gross enrolment ratio (%) in Pre-primary schools in 2001 to that in 2004?
Offer a terse response. 0.73. What is the ratio of the Gross enrolment ratio (%) of Primary schools in 2001 to that in 2004?
Your answer should be very brief. 1.02. What is the ratio of the Gross enrolment ratio (%) in Secondary schools in 2001 to that in 2004?
Make the answer very short. 0.8. What is the ratio of the Gross enrolment ratio (%) of Tertiary schools in 2001 to that in 2004?
Provide a succinct answer. 1. What is the ratio of the Gross enrolment ratio (%) in Pre-primary schools in 2001 to that in 2005?
Ensure brevity in your answer.  0.7. What is the ratio of the Gross enrolment ratio (%) in Primary schools in 2001 to that in 2005?
Make the answer very short. 1.03. What is the ratio of the Gross enrolment ratio (%) of Secondary schools in 2001 to that in 2005?
Offer a very short reply. 0.58. What is the ratio of the Gross enrolment ratio (%) in Pre-primary schools in 2001 to that in 2007?
Your answer should be very brief. 0.75. What is the ratio of the Gross enrolment ratio (%) of Secondary schools in 2001 to that in 2007?
Ensure brevity in your answer.  0.56. What is the ratio of the Gross enrolment ratio (%) in Tertiary schools in 2001 to that in 2007?
Give a very brief answer. 0.61. What is the ratio of the Gross enrolment ratio (%) in Pre-primary schools in 2003 to that in 2004?
Provide a short and direct response. 0.92. What is the ratio of the Gross enrolment ratio (%) in Primary schools in 2003 to that in 2004?
Your response must be concise. 1.01. What is the ratio of the Gross enrolment ratio (%) of Secondary schools in 2003 to that in 2004?
Offer a very short reply. 0.76. What is the ratio of the Gross enrolment ratio (%) of Tertiary schools in 2003 to that in 2004?
Keep it short and to the point. 1. What is the ratio of the Gross enrolment ratio (%) of Pre-primary schools in 2003 to that in 2005?
Keep it short and to the point. 0.88. What is the ratio of the Gross enrolment ratio (%) of Primary schools in 2003 to that in 2005?
Offer a very short reply. 1.02. What is the ratio of the Gross enrolment ratio (%) in Secondary schools in 2003 to that in 2005?
Offer a terse response. 0.55. What is the ratio of the Gross enrolment ratio (%) of Pre-primary schools in 2003 to that in 2007?
Ensure brevity in your answer.  0.95. What is the ratio of the Gross enrolment ratio (%) in Secondary schools in 2003 to that in 2007?
Provide a succinct answer. 0.54. What is the ratio of the Gross enrolment ratio (%) in Tertiary schools in 2003 to that in 2007?
Your response must be concise. 0.61. What is the ratio of the Gross enrolment ratio (%) in Pre-primary schools in 2004 to that in 2005?
Offer a very short reply. 0.96. What is the ratio of the Gross enrolment ratio (%) in Primary schools in 2004 to that in 2005?
Your answer should be compact. 1. What is the ratio of the Gross enrolment ratio (%) of Secondary schools in 2004 to that in 2005?
Your answer should be very brief. 0.72. What is the ratio of the Gross enrolment ratio (%) of Tertiary schools in 2004 to that in 2005?
Your answer should be very brief. 1.01. What is the ratio of the Gross enrolment ratio (%) of Pre-primary schools in 2004 to that in 2007?
Keep it short and to the point. 1.03. What is the ratio of the Gross enrolment ratio (%) in Primary schools in 2004 to that in 2007?
Ensure brevity in your answer.  0.98. What is the ratio of the Gross enrolment ratio (%) in Secondary schools in 2004 to that in 2007?
Offer a terse response. 0.7. What is the ratio of the Gross enrolment ratio (%) of Tertiary schools in 2004 to that in 2007?
Ensure brevity in your answer.  0.61. What is the ratio of the Gross enrolment ratio (%) of Pre-primary schools in 2005 to that in 2007?
Provide a succinct answer. 1.07. What is the ratio of the Gross enrolment ratio (%) in Primary schools in 2005 to that in 2007?
Offer a very short reply. 0.98. What is the ratio of the Gross enrolment ratio (%) of Secondary schools in 2005 to that in 2007?
Keep it short and to the point. 0.97. What is the ratio of the Gross enrolment ratio (%) in Tertiary schools in 2005 to that in 2007?
Ensure brevity in your answer.  0.61. What is the difference between the highest and the second highest Gross enrolment ratio (%) in Pre-primary schools?
Offer a very short reply. 3.17. What is the difference between the highest and the second highest Gross enrolment ratio (%) of Primary schools?
Keep it short and to the point. 0.41. What is the difference between the highest and the second highest Gross enrolment ratio (%) of Secondary schools?
Give a very brief answer. 2.08. What is the difference between the highest and the second highest Gross enrolment ratio (%) of Tertiary schools?
Your answer should be very brief. 2.1. What is the difference between the highest and the lowest Gross enrolment ratio (%) of Pre-primary schools?
Your answer should be compact. 28.98. What is the difference between the highest and the lowest Gross enrolment ratio (%) in Primary schools?
Your response must be concise. 3.35. What is the difference between the highest and the lowest Gross enrolment ratio (%) of Secondary schools?
Offer a very short reply. 36.11. What is the difference between the highest and the lowest Gross enrolment ratio (%) of Tertiary schools?
Your answer should be very brief. 2.22. 